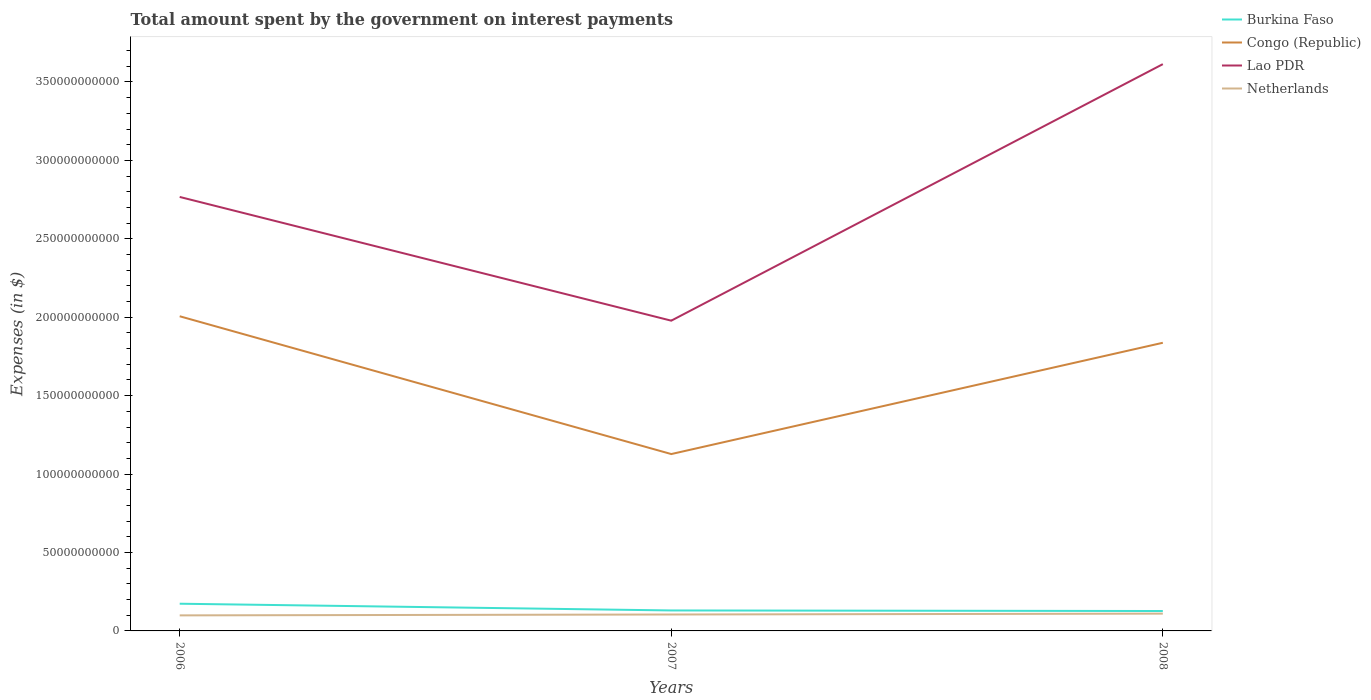How many different coloured lines are there?
Give a very brief answer. 4. Across all years, what is the maximum amount spent on interest payments by the government in Burkina Faso?
Provide a short and direct response. 1.27e+1. In which year was the amount spent on interest payments by the government in Burkina Faso maximum?
Give a very brief answer. 2008. What is the total amount spent on interest payments by the government in Netherlands in the graph?
Offer a terse response. -1.12e+09. What is the difference between the highest and the second highest amount spent on interest payments by the government in Lao PDR?
Make the answer very short. 1.64e+11. What is the difference between the highest and the lowest amount spent on interest payments by the government in Netherlands?
Provide a short and direct response. 1. How many lines are there?
Your answer should be very brief. 4. Are the values on the major ticks of Y-axis written in scientific E-notation?
Your answer should be very brief. No. Does the graph contain grids?
Provide a short and direct response. No. Where does the legend appear in the graph?
Ensure brevity in your answer.  Top right. How many legend labels are there?
Offer a very short reply. 4. What is the title of the graph?
Your answer should be compact. Total amount spent by the government on interest payments. Does "Sint Maarten (Dutch part)" appear as one of the legend labels in the graph?
Keep it short and to the point. No. What is the label or title of the Y-axis?
Ensure brevity in your answer.  Expenses (in $). What is the Expenses (in $) in Burkina Faso in 2006?
Give a very brief answer. 1.73e+1. What is the Expenses (in $) in Congo (Republic) in 2006?
Offer a terse response. 2.01e+11. What is the Expenses (in $) in Lao PDR in 2006?
Provide a succinct answer. 2.77e+11. What is the Expenses (in $) of Netherlands in 2006?
Offer a very short reply. 9.91e+09. What is the Expenses (in $) of Burkina Faso in 2007?
Offer a terse response. 1.31e+1. What is the Expenses (in $) of Congo (Republic) in 2007?
Provide a succinct answer. 1.13e+11. What is the Expenses (in $) in Lao PDR in 2007?
Ensure brevity in your answer.  1.98e+11. What is the Expenses (in $) in Netherlands in 2007?
Offer a very short reply. 1.05e+1. What is the Expenses (in $) in Burkina Faso in 2008?
Ensure brevity in your answer.  1.27e+1. What is the Expenses (in $) of Congo (Republic) in 2008?
Offer a terse response. 1.84e+11. What is the Expenses (in $) of Lao PDR in 2008?
Make the answer very short. 3.61e+11. What is the Expenses (in $) in Netherlands in 2008?
Give a very brief answer. 1.10e+1. Across all years, what is the maximum Expenses (in $) in Burkina Faso?
Offer a terse response. 1.73e+1. Across all years, what is the maximum Expenses (in $) in Congo (Republic)?
Your answer should be very brief. 2.01e+11. Across all years, what is the maximum Expenses (in $) in Lao PDR?
Your answer should be compact. 3.61e+11. Across all years, what is the maximum Expenses (in $) in Netherlands?
Keep it short and to the point. 1.10e+1. Across all years, what is the minimum Expenses (in $) of Burkina Faso?
Keep it short and to the point. 1.27e+1. Across all years, what is the minimum Expenses (in $) in Congo (Republic)?
Your answer should be compact. 1.13e+11. Across all years, what is the minimum Expenses (in $) in Lao PDR?
Offer a terse response. 1.98e+11. Across all years, what is the minimum Expenses (in $) of Netherlands?
Provide a short and direct response. 9.91e+09. What is the total Expenses (in $) in Burkina Faso in the graph?
Offer a terse response. 4.31e+1. What is the total Expenses (in $) in Congo (Republic) in the graph?
Offer a very short reply. 4.97e+11. What is the total Expenses (in $) of Lao PDR in the graph?
Provide a short and direct response. 8.36e+11. What is the total Expenses (in $) in Netherlands in the graph?
Offer a very short reply. 3.14e+1. What is the difference between the Expenses (in $) of Burkina Faso in 2006 and that in 2007?
Your answer should be very brief. 4.29e+09. What is the difference between the Expenses (in $) in Congo (Republic) in 2006 and that in 2007?
Offer a terse response. 8.79e+1. What is the difference between the Expenses (in $) in Lao PDR in 2006 and that in 2007?
Ensure brevity in your answer.  7.89e+1. What is the difference between the Expenses (in $) of Netherlands in 2006 and that in 2007?
Your response must be concise. -5.60e+08. What is the difference between the Expenses (in $) in Burkina Faso in 2006 and that in 2008?
Make the answer very short. 4.65e+09. What is the difference between the Expenses (in $) of Congo (Republic) in 2006 and that in 2008?
Offer a very short reply. 1.69e+1. What is the difference between the Expenses (in $) of Lao PDR in 2006 and that in 2008?
Ensure brevity in your answer.  -8.47e+1. What is the difference between the Expenses (in $) of Netherlands in 2006 and that in 2008?
Your answer should be very brief. -1.12e+09. What is the difference between the Expenses (in $) in Burkina Faso in 2007 and that in 2008?
Provide a short and direct response. 3.61e+08. What is the difference between the Expenses (in $) of Congo (Republic) in 2007 and that in 2008?
Provide a short and direct response. -7.10e+1. What is the difference between the Expenses (in $) in Lao PDR in 2007 and that in 2008?
Offer a very short reply. -1.64e+11. What is the difference between the Expenses (in $) in Netherlands in 2007 and that in 2008?
Offer a terse response. -5.60e+08. What is the difference between the Expenses (in $) in Burkina Faso in 2006 and the Expenses (in $) in Congo (Republic) in 2007?
Keep it short and to the point. -9.54e+1. What is the difference between the Expenses (in $) of Burkina Faso in 2006 and the Expenses (in $) of Lao PDR in 2007?
Your answer should be very brief. -1.80e+11. What is the difference between the Expenses (in $) in Burkina Faso in 2006 and the Expenses (in $) in Netherlands in 2007?
Provide a short and direct response. 6.88e+09. What is the difference between the Expenses (in $) in Congo (Republic) in 2006 and the Expenses (in $) in Lao PDR in 2007?
Give a very brief answer. 2.81e+09. What is the difference between the Expenses (in $) of Congo (Republic) in 2006 and the Expenses (in $) of Netherlands in 2007?
Ensure brevity in your answer.  1.90e+11. What is the difference between the Expenses (in $) in Lao PDR in 2006 and the Expenses (in $) in Netherlands in 2007?
Your answer should be very brief. 2.66e+11. What is the difference between the Expenses (in $) in Burkina Faso in 2006 and the Expenses (in $) in Congo (Republic) in 2008?
Ensure brevity in your answer.  -1.66e+11. What is the difference between the Expenses (in $) of Burkina Faso in 2006 and the Expenses (in $) of Lao PDR in 2008?
Offer a very short reply. -3.44e+11. What is the difference between the Expenses (in $) in Burkina Faso in 2006 and the Expenses (in $) in Netherlands in 2008?
Your response must be concise. 6.32e+09. What is the difference between the Expenses (in $) in Congo (Republic) in 2006 and the Expenses (in $) in Lao PDR in 2008?
Provide a succinct answer. -1.61e+11. What is the difference between the Expenses (in $) in Congo (Republic) in 2006 and the Expenses (in $) in Netherlands in 2008?
Keep it short and to the point. 1.90e+11. What is the difference between the Expenses (in $) of Lao PDR in 2006 and the Expenses (in $) of Netherlands in 2008?
Your answer should be very brief. 2.66e+11. What is the difference between the Expenses (in $) in Burkina Faso in 2007 and the Expenses (in $) in Congo (Republic) in 2008?
Your answer should be very brief. -1.71e+11. What is the difference between the Expenses (in $) in Burkina Faso in 2007 and the Expenses (in $) in Lao PDR in 2008?
Provide a short and direct response. -3.48e+11. What is the difference between the Expenses (in $) in Burkina Faso in 2007 and the Expenses (in $) in Netherlands in 2008?
Make the answer very short. 2.02e+09. What is the difference between the Expenses (in $) in Congo (Republic) in 2007 and the Expenses (in $) in Lao PDR in 2008?
Your answer should be very brief. -2.49e+11. What is the difference between the Expenses (in $) in Congo (Republic) in 2007 and the Expenses (in $) in Netherlands in 2008?
Ensure brevity in your answer.  1.02e+11. What is the difference between the Expenses (in $) in Lao PDR in 2007 and the Expenses (in $) in Netherlands in 2008?
Your response must be concise. 1.87e+11. What is the average Expenses (in $) of Burkina Faso per year?
Give a very brief answer. 1.44e+1. What is the average Expenses (in $) of Congo (Republic) per year?
Provide a short and direct response. 1.66e+11. What is the average Expenses (in $) of Lao PDR per year?
Your response must be concise. 2.79e+11. What is the average Expenses (in $) of Netherlands per year?
Ensure brevity in your answer.  1.05e+1. In the year 2006, what is the difference between the Expenses (in $) of Burkina Faso and Expenses (in $) of Congo (Republic)?
Provide a succinct answer. -1.83e+11. In the year 2006, what is the difference between the Expenses (in $) in Burkina Faso and Expenses (in $) in Lao PDR?
Provide a short and direct response. -2.59e+11. In the year 2006, what is the difference between the Expenses (in $) in Burkina Faso and Expenses (in $) in Netherlands?
Offer a very short reply. 7.44e+09. In the year 2006, what is the difference between the Expenses (in $) of Congo (Republic) and Expenses (in $) of Lao PDR?
Provide a succinct answer. -7.61e+1. In the year 2006, what is the difference between the Expenses (in $) of Congo (Republic) and Expenses (in $) of Netherlands?
Provide a short and direct response. 1.91e+11. In the year 2006, what is the difference between the Expenses (in $) of Lao PDR and Expenses (in $) of Netherlands?
Your answer should be compact. 2.67e+11. In the year 2007, what is the difference between the Expenses (in $) of Burkina Faso and Expenses (in $) of Congo (Republic)?
Your response must be concise. -9.97e+1. In the year 2007, what is the difference between the Expenses (in $) in Burkina Faso and Expenses (in $) in Lao PDR?
Offer a terse response. -1.85e+11. In the year 2007, what is the difference between the Expenses (in $) in Burkina Faso and Expenses (in $) in Netherlands?
Offer a terse response. 2.58e+09. In the year 2007, what is the difference between the Expenses (in $) of Congo (Republic) and Expenses (in $) of Lao PDR?
Offer a very short reply. -8.51e+1. In the year 2007, what is the difference between the Expenses (in $) in Congo (Republic) and Expenses (in $) in Netherlands?
Offer a very short reply. 1.02e+11. In the year 2007, what is the difference between the Expenses (in $) in Lao PDR and Expenses (in $) in Netherlands?
Ensure brevity in your answer.  1.87e+11. In the year 2008, what is the difference between the Expenses (in $) in Burkina Faso and Expenses (in $) in Congo (Republic)?
Your response must be concise. -1.71e+11. In the year 2008, what is the difference between the Expenses (in $) of Burkina Faso and Expenses (in $) of Lao PDR?
Your response must be concise. -3.49e+11. In the year 2008, what is the difference between the Expenses (in $) in Burkina Faso and Expenses (in $) in Netherlands?
Provide a succinct answer. 1.66e+09. In the year 2008, what is the difference between the Expenses (in $) in Congo (Republic) and Expenses (in $) in Lao PDR?
Provide a short and direct response. -1.78e+11. In the year 2008, what is the difference between the Expenses (in $) in Congo (Republic) and Expenses (in $) in Netherlands?
Your response must be concise. 1.73e+11. In the year 2008, what is the difference between the Expenses (in $) in Lao PDR and Expenses (in $) in Netherlands?
Provide a short and direct response. 3.50e+11. What is the ratio of the Expenses (in $) of Burkina Faso in 2006 to that in 2007?
Your answer should be very brief. 1.33. What is the ratio of the Expenses (in $) of Congo (Republic) in 2006 to that in 2007?
Provide a succinct answer. 1.78. What is the ratio of the Expenses (in $) of Lao PDR in 2006 to that in 2007?
Provide a short and direct response. 1.4. What is the ratio of the Expenses (in $) of Netherlands in 2006 to that in 2007?
Make the answer very short. 0.95. What is the ratio of the Expenses (in $) of Burkina Faso in 2006 to that in 2008?
Offer a very short reply. 1.37. What is the ratio of the Expenses (in $) of Congo (Republic) in 2006 to that in 2008?
Provide a short and direct response. 1.09. What is the ratio of the Expenses (in $) in Lao PDR in 2006 to that in 2008?
Make the answer very short. 0.77. What is the ratio of the Expenses (in $) of Netherlands in 2006 to that in 2008?
Your answer should be compact. 0.9. What is the ratio of the Expenses (in $) in Burkina Faso in 2007 to that in 2008?
Your answer should be very brief. 1.03. What is the ratio of the Expenses (in $) in Congo (Republic) in 2007 to that in 2008?
Make the answer very short. 0.61. What is the ratio of the Expenses (in $) of Lao PDR in 2007 to that in 2008?
Offer a terse response. 0.55. What is the ratio of the Expenses (in $) in Netherlands in 2007 to that in 2008?
Offer a terse response. 0.95. What is the difference between the highest and the second highest Expenses (in $) in Burkina Faso?
Provide a succinct answer. 4.29e+09. What is the difference between the highest and the second highest Expenses (in $) of Congo (Republic)?
Offer a very short reply. 1.69e+1. What is the difference between the highest and the second highest Expenses (in $) in Lao PDR?
Give a very brief answer. 8.47e+1. What is the difference between the highest and the second highest Expenses (in $) in Netherlands?
Make the answer very short. 5.60e+08. What is the difference between the highest and the lowest Expenses (in $) of Burkina Faso?
Provide a succinct answer. 4.65e+09. What is the difference between the highest and the lowest Expenses (in $) of Congo (Republic)?
Your answer should be compact. 8.79e+1. What is the difference between the highest and the lowest Expenses (in $) of Lao PDR?
Offer a very short reply. 1.64e+11. What is the difference between the highest and the lowest Expenses (in $) in Netherlands?
Give a very brief answer. 1.12e+09. 